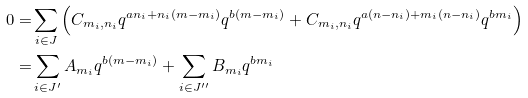<formula> <loc_0><loc_0><loc_500><loc_500>0 = & \sum _ { i \in J } \left ( C _ { m _ { i } , n _ { i } } q ^ { a n _ { i } + n _ { i } ( m - m _ { i } ) } q ^ { b ( m - m _ { i } ) } + C _ { m _ { i } , n _ { i } } q ^ { a ( n - n _ { i } ) + m _ { i } ( n - n _ { i } ) } q ^ { b m _ { i } } \right ) \\ = & \sum _ { i \in J ^ { \prime } } A _ { m _ { i } } q ^ { b ( m - m _ { i } ) } + \sum _ { i \in J ^ { \prime \prime } } B _ { m _ { i } } q ^ { b m _ { i } }</formula> 